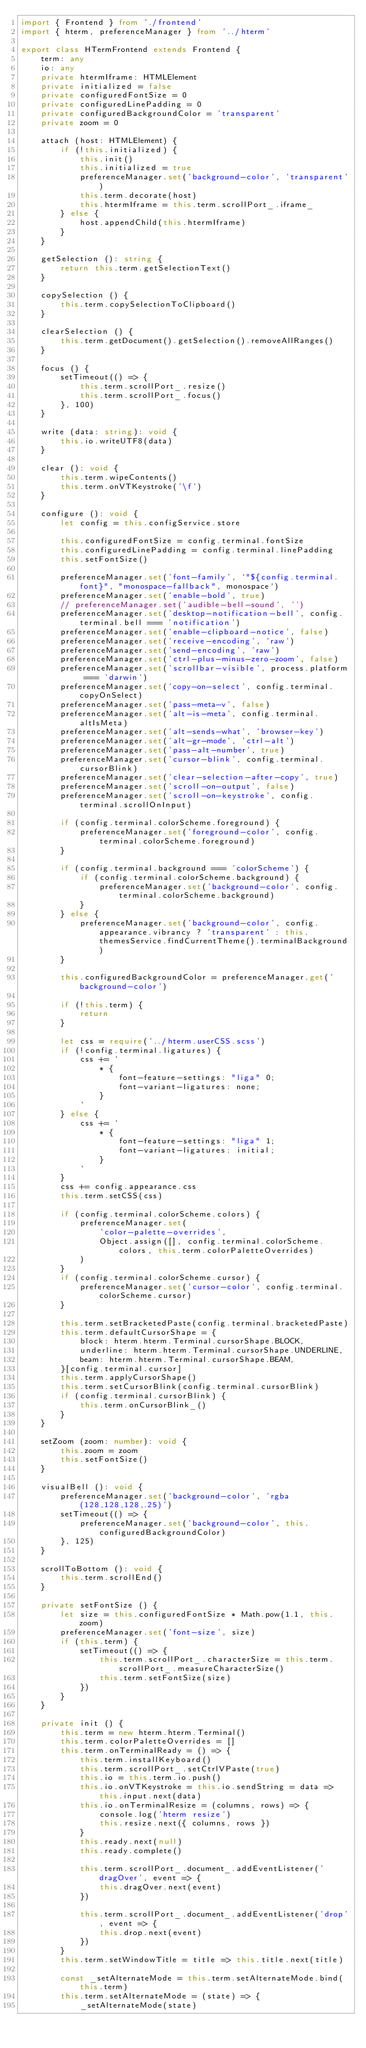<code> <loc_0><loc_0><loc_500><loc_500><_TypeScript_>import { Frontend } from './frontend'
import { hterm, preferenceManager } from '../hterm'

export class HTermFrontend extends Frontend {
    term: any
    io: any
    private htermIframe: HTMLElement
    private initialized = false
    private configuredFontSize = 0
    private configuredLinePadding = 0
    private configuredBackgroundColor = 'transparent'
    private zoom = 0

    attach (host: HTMLElement) {
        if (!this.initialized) {
            this.init()
            this.initialized = true
            preferenceManager.set('background-color', 'transparent')
            this.term.decorate(host)
            this.htermIframe = this.term.scrollPort_.iframe_
        } else {
            host.appendChild(this.htermIframe)
        }
    }

    getSelection (): string {
        return this.term.getSelectionText()
    }

    copySelection () {
        this.term.copySelectionToClipboard()
    }

    clearSelection () {
        this.term.getDocument().getSelection().removeAllRanges()
    }

    focus () {
        setTimeout(() => {
            this.term.scrollPort_.resize()
            this.term.scrollPort_.focus()
        }, 100)
    }

    write (data: string): void {
        this.io.writeUTF8(data)
    }

    clear (): void {
        this.term.wipeContents()
        this.term.onVTKeystroke('\f')
    }

    configure (): void {
        let config = this.configService.store

        this.configuredFontSize = config.terminal.fontSize
        this.configuredLinePadding = config.terminal.linePadding
        this.setFontSize()

        preferenceManager.set('font-family', `"${config.terminal.font}", "monospace-fallback", monospace`)
        preferenceManager.set('enable-bold', true)
        // preferenceManager.set('audible-bell-sound', '')
        preferenceManager.set('desktop-notification-bell', config.terminal.bell === 'notification')
        preferenceManager.set('enable-clipboard-notice', false)
        preferenceManager.set('receive-encoding', 'raw')
        preferenceManager.set('send-encoding', 'raw')
        preferenceManager.set('ctrl-plus-minus-zero-zoom', false)
        preferenceManager.set('scrollbar-visible', process.platform === 'darwin')
        preferenceManager.set('copy-on-select', config.terminal.copyOnSelect)
        preferenceManager.set('pass-meta-v', false)
        preferenceManager.set('alt-is-meta', config.terminal.altIsMeta)
        preferenceManager.set('alt-sends-what', 'browser-key')
        preferenceManager.set('alt-gr-mode', 'ctrl-alt')
        preferenceManager.set('pass-alt-number', true)
        preferenceManager.set('cursor-blink', config.terminal.cursorBlink)
        preferenceManager.set('clear-selection-after-copy', true)
        preferenceManager.set('scroll-on-output', false)
        preferenceManager.set('scroll-on-keystroke', config.terminal.scrollOnInput)

        if (config.terminal.colorScheme.foreground) {
            preferenceManager.set('foreground-color', config.terminal.colorScheme.foreground)
        }

        if (config.terminal.background === 'colorScheme') {
            if (config.terminal.colorScheme.background) {
                preferenceManager.set('background-color', config.terminal.colorScheme.background)
            }
        } else {
            preferenceManager.set('background-color', config.appearance.vibrancy ? 'transparent' : this.themesService.findCurrentTheme().terminalBackground)
        }

        this.configuredBackgroundColor = preferenceManager.get('background-color')

        if (!this.term) {
            return
        }

        let css = require('../hterm.userCSS.scss')
        if (!config.terminal.ligatures) {
            css += `
                * {
                    font-feature-settings: "liga" 0;
                    font-variant-ligatures: none;
                }
            `
        } else {
            css += `
                * {
                    font-feature-settings: "liga" 1;
                    font-variant-ligatures: initial;
                }
            `
        }
        css += config.appearance.css
        this.term.setCSS(css)

        if (config.terminal.colorScheme.colors) {
            preferenceManager.set(
                'color-palette-overrides',
                Object.assign([], config.terminal.colorScheme.colors, this.term.colorPaletteOverrides)
            )
        }
        if (config.terminal.colorScheme.cursor) {
            preferenceManager.set('cursor-color', config.terminal.colorScheme.cursor)
        }

        this.term.setBracketedPaste(config.terminal.bracketedPaste)
        this.term.defaultCursorShape = {
            block: hterm.hterm.Terminal.cursorShape.BLOCK,
            underline: hterm.hterm.Terminal.cursorShape.UNDERLINE,
            beam: hterm.hterm.Terminal.cursorShape.BEAM,
        }[config.terminal.cursor]
        this.term.applyCursorShape()
        this.term.setCursorBlink(config.terminal.cursorBlink)
        if (config.terminal.cursorBlink) {
            this.term.onCursorBlink_()
        }
    }

    setZoom (zoom: number): void {
        this.zoom = zoom
        this.setFontSize()
    }

    visualBell (): void {
        preferenceManager.set('background-color', 'rgba(128,128,128,.25)')
        setTimeout(() => {
            preferenceManager.set('background-color', this.configuredBackgroundColor)
        }, 125)
    }

    scrollToBottom (): void {
        this.term.scrollEnd()
    }

    private setFontSize () {
        let size = this.configuredFontSize * Math.pow(1.1, this.zoom)
        preferenceManager.set('font-size', size)
        if (this.term) {
            setTimeout(() => {
                this.term.scrollPort_.characterSize = this.term.scrollPort_.measureCharacterSize()
                this.term.setFontSize(size)
            })
        }
    }

    private init () {
        this.term = new hterm.hterm.Terminal()
        this.term.colorPaletteOverrides = []
        this.term.onTerminalReady = () => {
            this.term.installKeyboard()
            this.term.scrollPort_.setCtrlVPaste(true)
            this.io = this.term.io.push()
            this.io.onVTKeystroke = this.io.sendString = data => this.input.next(data)
            this.io.onTerminalResize = (columns, rows) => {
                console.log('hterm resize')
                this.resize.next({ columns, rows })
            }
            this.ready.next(null)
            this.ready.complete()

            this.term.scrollPort_.document_.addEventListener('dragOver', event => {
                this.dragOver.next(event)
            })

            this.term.scrollPort_.document_.addEventListener('drop', event => {
                this.drop.next(event)
            })
        }
        this.term.setWindowTitle = title => this.title.next(title)

        const _setAlternateMode = this.term.setAlternateMode.bind(this.term)
        this.term.setAlternateMode = (state) => {
            _setAlternateMode(state)</code> 